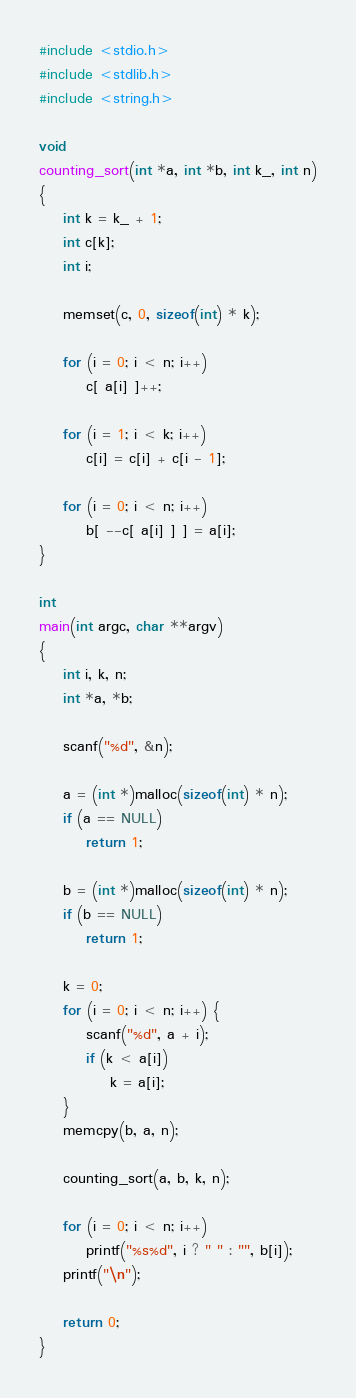Convert code to text. <code><loc_0><loc_0><loc_500><loc_500><_C_>#include <stdio.h>
#include <stdlib.h>
#include <string.h>

void
counting_sort(int *a, int *b, int k_, int n)
{
	int k = k_ + 1;
	int c[k];
	int i;

	memset(c, 0, sizeof(int) * k);

	for (i = 0; i < n; i++)
		c[ a[i] ]++;

	for (i = 1; i < k; i++)
		c[i] = c[i] + c[i - 1];

	for (i = 0; i < n; i++)
		b[ --c[ a[i] ] ] = a[i];
}

int
main(int argc, char **argv)
{
	int i, k, n;
	int *a, *b;

	scanf("%d", &n);

	a = (int *)malloc(sizeof(int) * n);
	if (a == NULL)
		return 1;

	b = (int *)malloc(sizeof(int) * n);
	if (b == NULL)
		return 1;

	k = 0;
	for (i = 0; i < n; i++) {
		scanf("%d", a + i);
		if (k < a[i])
			k = a[i];
	}
	memcpy(b, a, n);

	counting_sort(a, b, k, n);

	for (i = 0; i < n; i++)
		printf("%s%d", i ? " " : "", b[i]);
	printf("\n");

	return 0;
}

</code> 